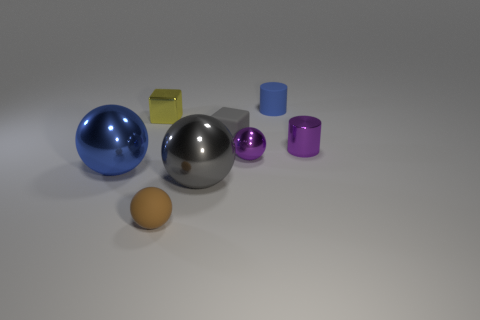Subtract all blue spheres. How many spheres are left? 3 Subtract 1 spheres. How many spheres are left? 3 Subtract all purple spheres. How many spheres are left? 3 Add 2 small green objects. How many objects exist? 10 Subtract all brown balls. Subtract all green blocks. How many balls are left? 3 Subtract all blocks. How many objects are left? 6 Subtract all big metal cylinders. Subtract all purple shiny cylinders. How many objects are left? 7 Add 3 big blue spheres. How many big blue spheres are left? 4 Add 8 tiny yellow rubber cylinders. How many tiny yellow rubber cylinders exist? 8 Subtract 1 gray cubes. How many objects are left? 7 